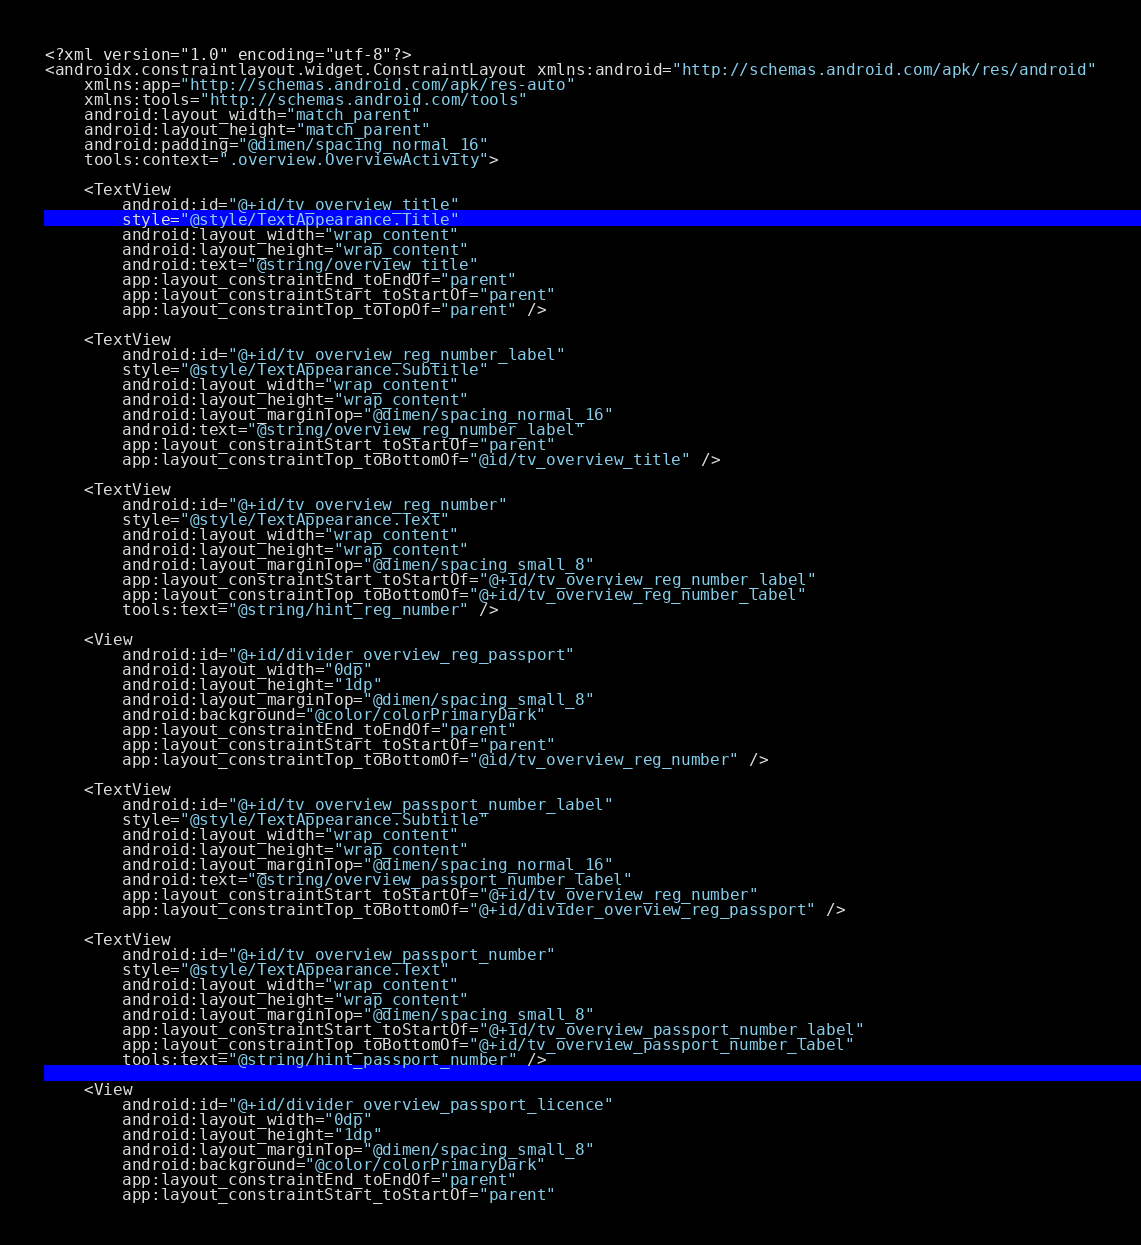Convert code to text. <code><loc_0><loc_0><loc_500><loc_500><_XML_><?xml version="1.0" encoding="utf-8"?>
<androidx.constraintlayout.widget.ConstraintLayout xmlns:android="http://schemas.android.com/apk/res/android"
    xmlns:app="http://schemas.android.com/apk/res-auto"
    xmlns:tools="http://schemas.android.com/tools"
    android:layout_width="match_parent"
    android:layout_height="match_parent"
    android:padding="@dimen/spacing_normal_16"
    tools:context=".overview.OverviewActivity">

    <TextView
        android:id="@+id/tv_overview_title"
        style="@style/TextAppearance.Title"
        android:layout_width="wrap_content"
        android:layout_height="wrap_content"
        android:text="@string/overview_title"
        app:layout_constraintEnd_toEndOf="parent"
        app:layout_constraintStart_toStartOf="parent"
        app:layout_constraintTop_toTopOf="parent" />

    <TextView
        android:id="@+id/tv_overview_reg_number_label"
        style="@style/TextAppearance.Subtitle"
        android:layout_width="wrap_content"
        android:layout_height="wrap_content"
        android:layout_marginTop="@dimen/spacing_normal_16"
        android:text="@string/overview_reg_number_label"
        app:layout_constraintStart_toStartOf="parent"
        app:layout_constraintTop_toBottomOf="@id/tv_overview_title" />

    <TextView
        android:id="@+id/tv_overview_reg_number"
        style="@style/TextAppearance.Text"
        android:layout_width="wrap_content"
        android:layout_height="wrap_content"
        android:layout_marginTop="@dimen/spacing_small_8"
        app:layout_constraintStart_toStartOf="@+id/tv_overview_reg_number_label"
        app:layout_constraintTop_toBottomOf="@+id/tv_overview_reg_number_label"
        tools:text="@string/hint_reg_number" />

    <View
        android:id="@+id/divider_overview_reg_passport"
        android:layout_width="0dp"
        android:layout_height="1dp"
        android:layout_marginTop="@dimen/spacing_small_8"
        android:background="@color/colorPrimaryDark"
        app:layout_constraintEnd_toEndOf="parent"
        app:layout_constraintStart_toStartOf="parent"
        app:layout_constraintTop_toBottomOf="@id/tv_overview_reg_number" />

    <TextView
        android:id="@+id/tv_overview_passport_number_label"
        style="@style/TextAppearance.Subtitle"
        android:layout_width="wrap_content"
        android:layout_height="wrap_content"
        android:layout_marginTop="@dimen/spacing_normal_16"
        android:text="@string/overview_passport_number_label"
        app:layout_constraintStart_toStartOf="@+id/tv_overview_reg_number"
        app:layout_constraintTop_toBottomOf="@+id/divider_overview_reg_passport" />

    <TextView
        android:id="@+id/tv_overview_passport_number"
        style="@style/TextAppearance.Text"
        android:layout_width="wrap_content"
        android:layout_height="wrap_content"
        android:layout_marginTop="@dimen/spacing_small_8"
        app:layout_constraintStart_toStartOf="@+id/tv_overview_passport_number_label"
        app:layout_constraintTop_toBottomOf="@+id/tv_overview_passport_number_label"
        tools:text="@string/hint_passport_number" />

    <View
        android:id="@+id/divider_overview_passport_licence"
        android:layout_width="0dp"
        android:layout_height="1dp"
        android:layout_marginTop="@dimen/spacing_small_8"
        android:background="@color/colorPrimaryDark"
        app:layout_constraintEnd_toEndOf="parent"
        app:layout_constraintStart_toStartOf="parent"</code> 